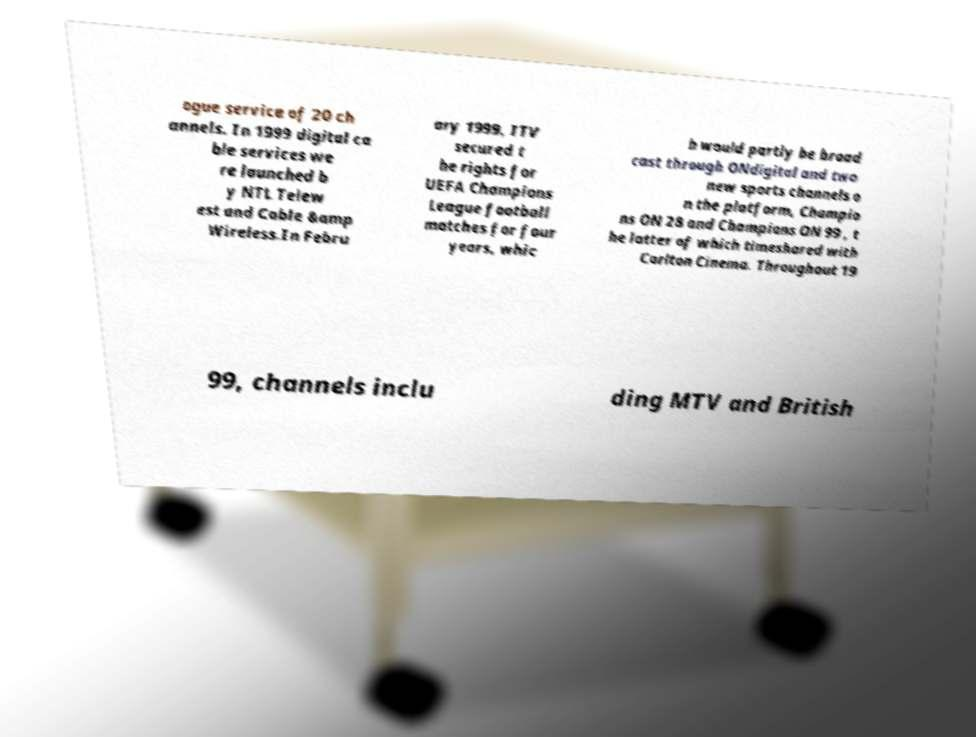What messages or text are displayed in this image? I need them in a readable, typed format. ogue service of 20 ch annels. In 1999 digital ca ble services we re launched b y NTL Telew est and Cable &amp Wireless.In Febru ary 1999, ITV secured t he rights for UEFA Champions League football matches for four years, whic h would partly be broad cast through ONdigital and two new sports channels o n the platform, Champio ns ON 28 and Champions ON 99 , t he latter of which timeshared with Carlton Cinema. Throughout 19 99, channels inclu ding MTV and British 